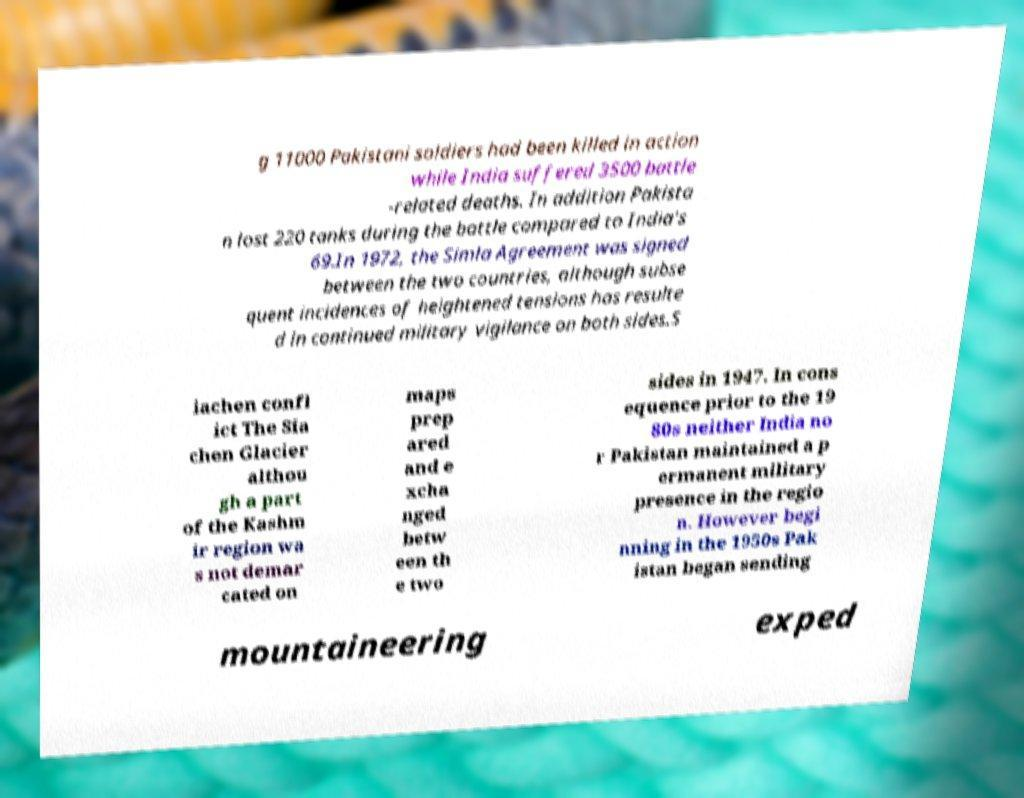There's text embedded in this image that I need extracted. Can you transcribe it verbatim? g 11000 Pakistani soldiers had been killed in action while India suffered 3500 battle -related deaths. In addition Pakista n lost 220 tanks during the battle compared to India's 69.In 1972, the Simla Agreement was signed between the two countries, although subse quent incidences of heightened tensions has resulte d in continued military vigilance on both sides.S iachen confl ict The Sia chen Glacier althou gh a part of the Kashm ir region wa s not demar cated on maps prep ared and e xcha nged betw een th e two sides in 1947. In cons equence prior to the 19 80s neither India no r Pakistan maintained a p ermanent military presence in the regio n. However begi nning in the 1950s Pak istan began sending mountaineering exped 